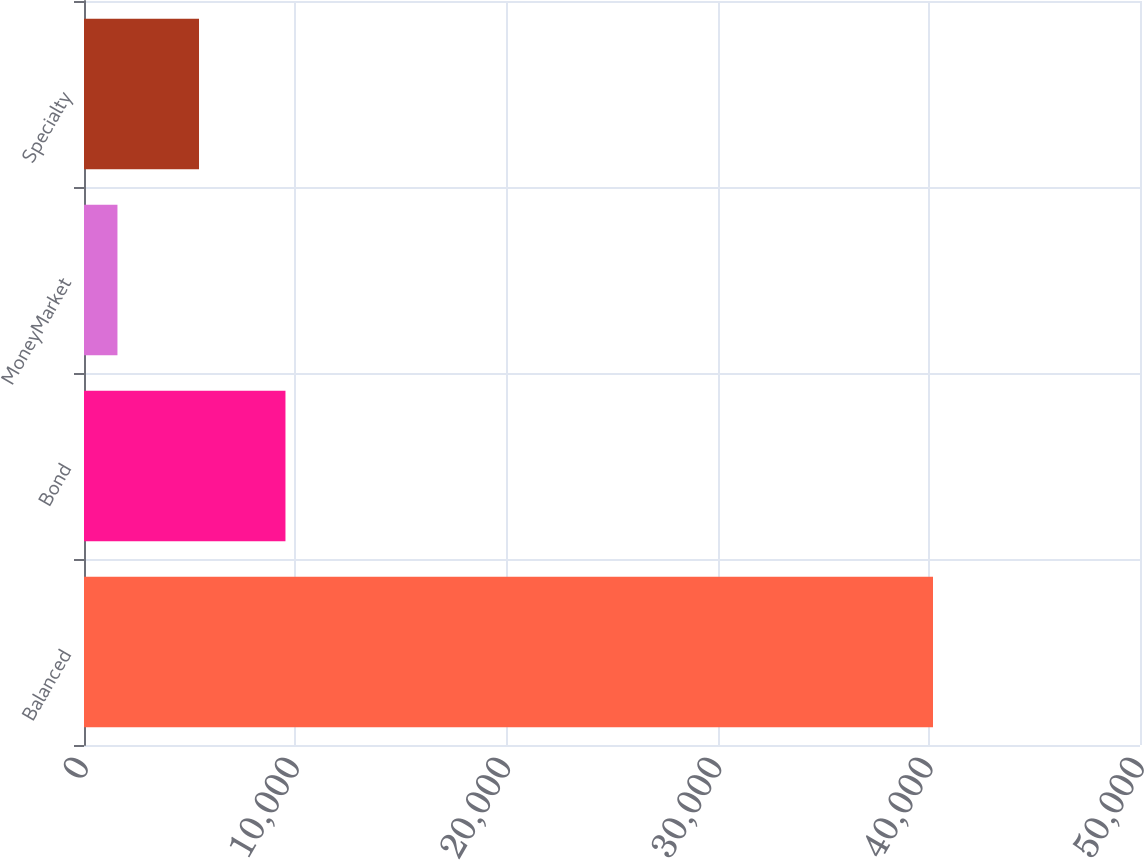<chart> <loc_0><loc_0><loc_500><loc_500><bar_chart><fcel>Balanced<fcel>Bond<fcel>MoneyMarket<fcel>Specialty<nl><fcel>40199<fcel>9539<fcel>1584<fcel>5445.5<nl></chart> 